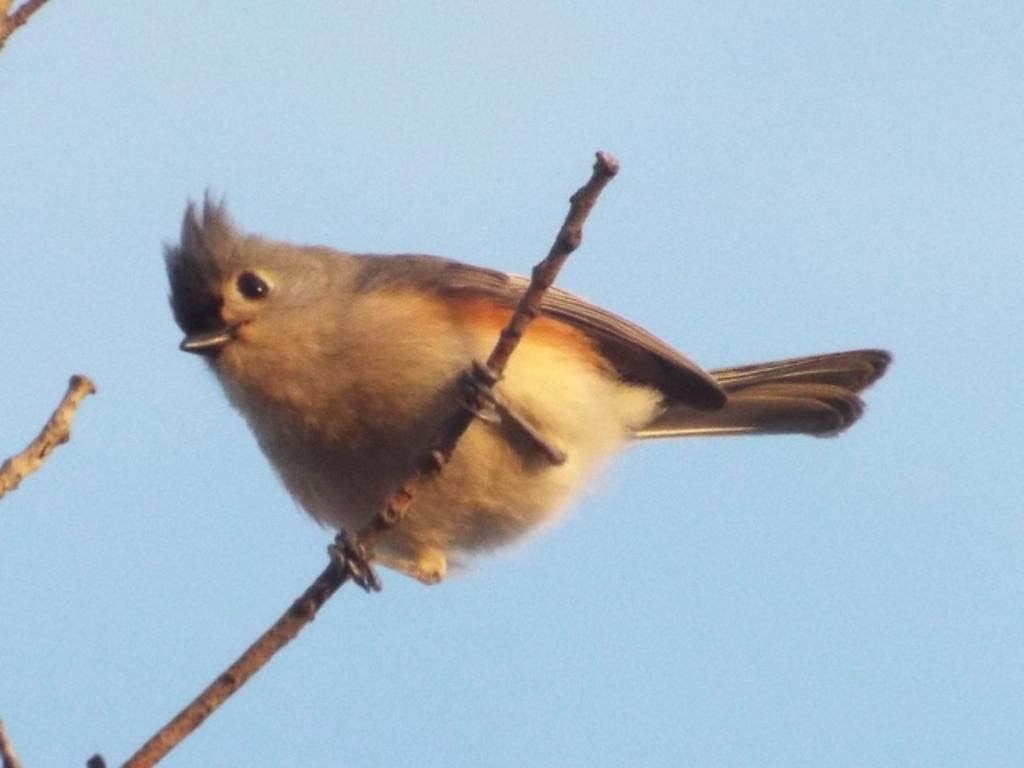What type of animal is in the image? There is a bird in the image. How is the bird positioned in the image? The bird is on a stick. What colors can be seen on the bird? The bird has cream and brown colors. What can be seen in the background of the image? The sky is visible in the background of the image. How many geese are flying in the image? There are no geese present in the image; it features a bird on a stick. What rule is being enforced in the image? There is no rule being enforced in the image; it is a picture of a bird on a stick with a sky background. 